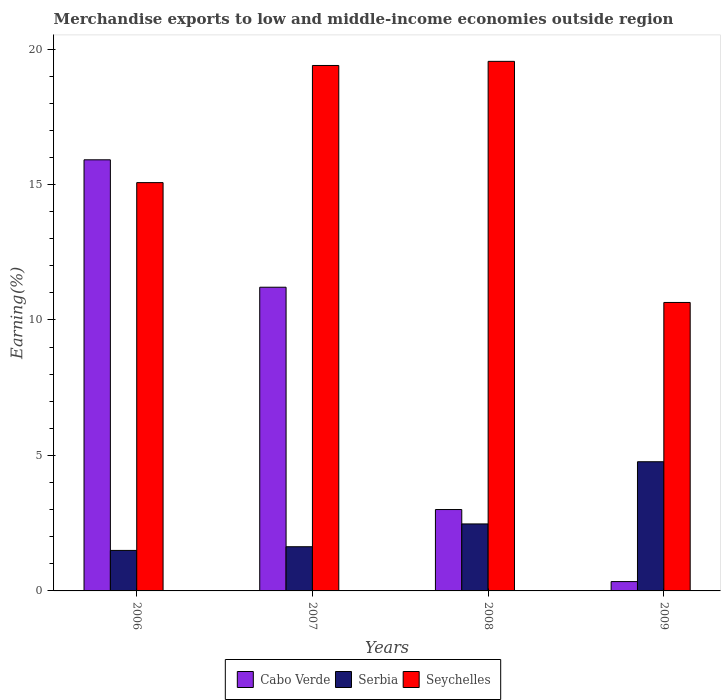How many groups of bars are there?
Offer a very short reply. 4. Are the number of bars per tick equal to the number of legend labels?
Offer a terse response. Yes. Are the number of bars on each tick of the X-axis equal?
Offer a terse response. Yes. What is the label of the 2nd group of bars from the left?
Make the answer very short. 2007. What is the percentage of amount earned from merchandise exports in Serbia in 2009?
Offer a very short reply. 4.77. Across all years, what is the maximum percentage of amount earned from merchandise exports in Seychelles?
Your answer should be very brief. 19.54. Across all years, what is the minimum percentage of amount earned from merchandise exports in Cabo Verde?
Ensure brevity in your answer.  0.34. In which year was the percentage of amount earned from merchandise exports in Serbia maximum?
Your response must be concise. 2009. What is the total percentage of amount earned from merchandise exports in Serbia in the graph?
Ensure brevity in your answer.  10.37. What is the difference between the percentage of amount earned from merchandise exports in Seychelles in 2006 and that in 2009?
Your answer should be very brief. 4.42. What is the difference between the percentage of amount earned from merchandise exports in Cabo Verde in 2008 and the percentage of amount earned from merchandise exports in Serbia in 2006?
Give a very brief answer. 1.51. What is the average percentage of amount earned from merchandise exports in Seychelles per year?
Your answer should be very brief. 16.16. In the year 2007, what is the difference between the percentage of amount earned from merchandise exports in Seychelles and percentage of amount earned from merchandise exports in Cabo Verde?
Provide a succinct answer. 8.18. In how many years, is the percentage of amount earned from merchandise exports in Serbia greater than 18 %?
Keep it short and to the point. 0. What is the ratio of the percentage of amount earned from merchandise exports in Seychelles in 2006 to that in 2008?
Your response must be concise. 0.77. What is the difference between the highest and the second highest percentage of amount earned from merchandise exports in Serbia?
Provide a short and direct response. 2.29. What is the difference between the highest and the lowest percentage of amount earned from merchandise exports in Seychelles?
Keep it short and to the point. 8.9. What does the 3rd bar from the left in 2007 represents?
Ensure brevity in your answer.  Seychelles. What does the 2nd bar from the right in 2006 represents?
Provide a succinct answer. Serbia. How many bars are there?
Your response must be concise. 12. What is the difference between two consecutive major ticks on the Y-axis?
Keep it short and to the point. 5. Are the values on the major ticks of Y-axis written in scientific E-notation?
Offer a terse response. No. Does the graph contain any zero values?
Provide a succinct answer. No. Does the graph contain grids?
Your response must be concise. No. Where does the legend appear in the graph?
Offer a very short reply. Bottom center. How many legend labels are there?
Provide a succinct answer. 3. How are the legend labels stacked?
Your answer should be very brief. Horizontal. What is the title of the graph?
Keep it short and to the point. Merchandise exports to low and middle-income economies outside region. What is the label or title of the Y-axis?
Ensure brevity in your answer.  Earning(%). What is the Earning(%) of Cabo Verde in 2006?
Provide a short and direct response. 15.91. What is the Earning(%) in Serbia in 2006?
Your answer should be compact. 1.5. What is the Earning(%) in Seychelles in 2006?
Keep it short and to the point. 15.07. What is the Earning(%) of Cabo Verde in 2007?
Offer a very short reply. 11.21. What is the Earning(%) in Serbia in 2007?
Provide a succinct answer. 1.63. What is the Earning(%) in Seychelles in 2007?
Make the answer very short. 19.39. What is the Earning(%) of Cabo Verde in 2008?
Offer a very short reply. 3. What is the Earning(%) of Serbia in 2008?
Your response must be concise. 2.47. What is the Earning(%) in Seychelles in 2008?
Provide a succinct answer. 19.54. What is the Earning(%) of Cabo Verde in 2009?
Give a very brief answer. 0.34. What is the Earning(%) in Serbia in 2009?
Offer a terse response. 4.77. What is the Earning(%) of Seychelles in 2009?
Your answer should be very brief. 10.65. Across all years, what is the maximum Earning(%) in Cabo Verde?
Offer a terse response. 15.91. Across all years, what is the maximum Earning(%) of Serbia?
Keep it short and to the point. 4.77. Across all years, what is the maximum Earning(%) in Seychelles?
Your answer should be compact. 19.54. Across all years, what is the minimum Earning(%) of Cabo Verde?
Ensure brevity in your answer.  0.34. Across all years, what is the minimum Earning(%) of Serbia?
Ensure brevity in your answer.  1.5. Across all years, what is the minimum Earning(%) of Seychelles?
Provide a short and direct response. 10.65. What is the total Earning(%) of Cabo Verde in the graph?
Give a very brief answer. 30.47. What is the total Earning(%) of Serbia in the graph?
Provide a short and direct response. 10.37. What is the total Earning(%) in Seychelles in the graph?
Offer a terse response. 64.65. What is the difference between the Earning(%) in Cabo Verde in 2006 and that in 2007?
Ensure brevity in your answer.  4.7. What is the difference between the Earning(%) of Serbia in 2006 and that in 2007?
Provide a succinct answer. -0.14. What is the difference between the Earning(%) in Seychelles in 2006 and that in 2007?
Keep it short and to the point. -4.32. What is the difference between the Earning(%) in Cabo Verde in 2006 and that in 2008?
Keep it short and to the point. 12.91. What is the difference between the Earning(%) of Serbia in 2006 and that in 2008?
Give a very brief answer. -0.98. What is the difference between the Earning(%) in Seychelles in 2006 and that in 2008?
Provide a short and direct response. -4.48. What is the difference between the Earning(%) in Cabo Verde in 2006 and that in 2009?
Offer a terse response. 15.57. What is the difference between the Earning(%) of Serbia in 2006 and that in 2009?
Your response must be concise. -3.27. What is the difference between the Earning(%) of Seychelles in 2006 and that in 2009?
Provide a short and direct response. 4.42. What is the difference between the Earning(%) of Cabo Verde in 2007 and that in 2008?
Make the answer very short. 8.2. What is the difference between the Earning(%) in Serbia in 2007 and that in 2008?
Your response must be concise. -0.84. What is the difference between the Earning(%) in Seychelles in 2007 and that in 2008?
Provide a short and direct response. -0.15. What is the difference between the Earning(%) in Cabo Verde in 2007 and that in 2009?
Ensure brevity in your answer.  10.86. What is the difference between the Earning(%) of Serbia in 2007 and that in 2009?
Make the answer very short. -3.14. What is the difference between the Earning(%) of Seychelles in 2007 and that in 2009?
Give a very brief answer. 8.75. What is the difference between the Earning(%) in Cabo Verde in 2008 and that in 2009?
Provide a short and direct response. 2.66. What is the difference between the Earning(%) of Serbia in 2008 and that in 2009?
Provide a short and direct response. -2.29. What is the difference between the Earning(%) in Seychelles in 2008 and that in 2009?
Provide a succinct answer. 8.9. What is the difference between the Earning(%) of Cabo Verde in 2006 and the Earning(%) of Serbia in 2007?
Offer a very short reply. 14.28. What is the difference between the Earning(%) of Cabo Verde in 2006 and the Earning(%) of Seychelles in 2007?
Your response must be concise. -3.48. What is the difference between the Earning(%) of Serbia in 2006 and the Earning(%) of Seychelles in 2007?
Make the answer very short. -17.9. What is the difference between the Earning(%) in Cabo Verde in 2006 and the Earning(%) in Serbia in 2008?
Offer a very short reply. 13.44. What is the difference between the Earning(%) of Cabo Verde in 2006 and the Earning(%) of Seychelles in 2008?
Give a very brief answer. -3.63. What is the difference between the Earning(%) of Serbia in 2006 and the Earning(%) of Seychelles in 2008?
Provide a short and direct response. -18.05. What is the difference between the Earning(%) in Cabo Verde in 2006 and the Earning(%) in Serbia in 2009?
Your answer should be compact. 11.14. What is the difference between the Earning(%) in Cabo Verde in 2006 and the Earning(%) in Seychelles in 2009?
Provide a succinct answer. 5.26. What is the difference between the Earning(%) of Serbia in 2006 and the Earning(%) of Seychelles in 2009?
Offer a terse response. -9.15. What is the difference between the Earning(%) in Cabo Verde in 2007 and the Earning(%) in Serbia in 2008?
Your response must be concise. 8.74. What is the difference between the Earning(%) in Cabo Verde in 2007 and the Earning(%) in Seychelles in 2008?
Ensure brevity in your answer.  -8.34. What is the difference between the Earning(%) in Serbia in 2007 and the Earning(%) in Seychelles in 2008?
Keep it short and to the point. -17.91. What is the difference between the Earning(%) in Cabo Verde in 2007 and the Earning(%) in Serbia in 2009?
Give a very brief answer. 6.44. What is the difference between the Earning(%) of Cabo Verde in 2007 and the Earning(%) of Seychelles in 2009?
Offer a terse response. 0.56. What is the difference between the Earning(%) of Serbia in 2007 and the Earning(%) of Seychelles in 2009?
Your answer should be compact. -9.02. What is the difference between the Earning(%) of Cabo Verde in 2008 and the Earning(%) of Serbia in 2009?
Your answer should be very brief. -1.76. What is the difference between the Earning(%) of Cabo Verde in 2008 and the Earning(%) of Seychelles in 2009?
Your answer should be very brief. -7.64. What is the difference between the Earning(%) of Serbia in 2008 and the Earning(%) of Seychelles in 2009?
Give a very brief answer. -8.17. What is the average Earning(%) in Cabo Verde per year?
Make the answer very short. 7.62. What is the average Earning(%) in Serbia per year?
Make the answer very short. 2.59. What is the average Earning(%) in Seychelles per year?
Ensure brevity in your answer.  16.16. In the year 2006, what is the difference between the Earning(%) in Cabo Verde and Earning(%) in Serbia?
Your answer should be compact. 14.42. In the year 2006, what is the difference between the Earning(%) of Cabo Verde and Earning(%) of Seychelles?
Provide a succinct answer. 0.84. In the year 2006, what is the difference between the Earning(%) of Serbia and Earning(%) of Seychelles?
Give a very brief answer. -13.57. In the year 2007, what is the difference between the Earning(%) of Cabo Verde and Earning(%) of Serbia?
Offer a very short reply. 9.58. In the year 2007, what is the difference between the Earning(%) of Cabo Verde and Earning(%) of Seychelles?
Offer a terse response. -8.18. In the year 2007, what is the difference between the Earning(%) in Serbia and Earning(%) in Seychelles?
Your answer should be very brief. -17.76. In the year 2008, what is the difference between the Earning(%) of Cabo Verde and Earning(%) of Serbia?
Your response must be concise. 0.53. In the year 2008, what is the difference between the Earning(%) in Cabo Verde and Earning(%) in Seychelles?
Keep it short and to the point. -16.54. In the year 2008, what is the difference between the Earning(%) in Serbia and Earning(%) in Seychelles?
Your response must be concise. -17.07. In the year 2009, what is the difference between the Earning(%) in Cabo Verde and Earning(%) in Serbia?
Provide a succinct answer. -4.42. In the year 2009, what is the difference between the Earning(%) in Cabo Verde and Earning(%) in Seychelles?
Provide a short and direct response. -10.3. In the year 2009, what is the difference between the Earning(%) of Serbia and Earning(%) of Seychelles?
Offer a terse response. -5.88. What is the ratio of the Earning(%) in Cabo Verde in 2006 to that in 2007?
Give a very brief answer. 1.42. What is the ratio of the Earning(%) of Serbia in 2006 to that in 2007?
Make the answer very short. 0.92. What is the ratio of the Earning(%) in Seychelles in 2006 to that in 2007?
Your response must be concise. 0.78. What is the ratio of the Earning(%) of Cabo Verde in 2006 to that in 2008?
Provide a short and direct response. 5.3. What is the ratio of the Earning(%) of Serbia in 2006 to that in 2008?
Make the answer very short. 0.6. What is the ratio of the Earning(%) of Seychelles in 2006 to that in 2008?
Your answer should be compact. 0.77. What is the ratio of the Earning(%) in Cabo Verde in 2006 to that in 2009?
Your answer should be compact. 46.2. What is the ratio of the Earning(%) of Serbia in 2006 to that in 2009?
Offer a very short reply. 0.31. What is the ratio of the Earning(%) in Seychelles in 2006 to that in 2009?
Your answer should be very brief. 1.42. What is the ratio of the Earning(%) of Cabo Verde in 2007 to that in 2008?
Keep it short and to the point. 3.73. What is the ratio of the Earning(%) of Serbia in 2007 to that in 2008?
Keep it short and to the point. 0.66. What is the ratio of the Earning(%) in Seychelles in 2007 to that in 2008?
Keep it short and to the point. 0.99. What is the ratio of the Earning(%) of Cabo Verde in 2007 to that in 2009?
Keep it short and to the point. 32.54. What is the ratio of the Earning(%) in Serbia in 2007 to that in 2009?
Make the answer very short. 0.34. What is the ratio of the Earning(%) of Seychelles in 2007 to that in 2009?
Make the answer very short. 1.82. What is the ratio of the Earning(%) in Cabo Verde in 2008 to that in 2009?
Offer a very short reply. 8.72. What is the ratio of the Earning(%) in Serbia in 2008 to that in 2009?
Provide a short and direct response. 0.52. What is the ratio of the Earning(%) of Seychelles in 2008 to that in 2009?
Provide a short and direct response. 1.84. What is the difference between the highest and the second highest Earning(%) of Cabo Verde?
Make the answer very short. 4.7. What is the difference between the highest and the second highest Earning(%) of Serbia?
Give a very brief answer. 2.29. What is the difference between the highest and the second highest Earning(%) of Seychelles?
Offer a terse response. 0.15. What is the difference between the highest and the lowest Earning(%) in Cabo Verde?
Your response must be concise. 15.57. What is the difference between the highest and the lowest Earning(%) in Serbia?
Keep it short and to the point. 3.27. What is the difference between the highest and the lowest Earning(%) in Seychelles?
Make the answer very short. 8.9. 